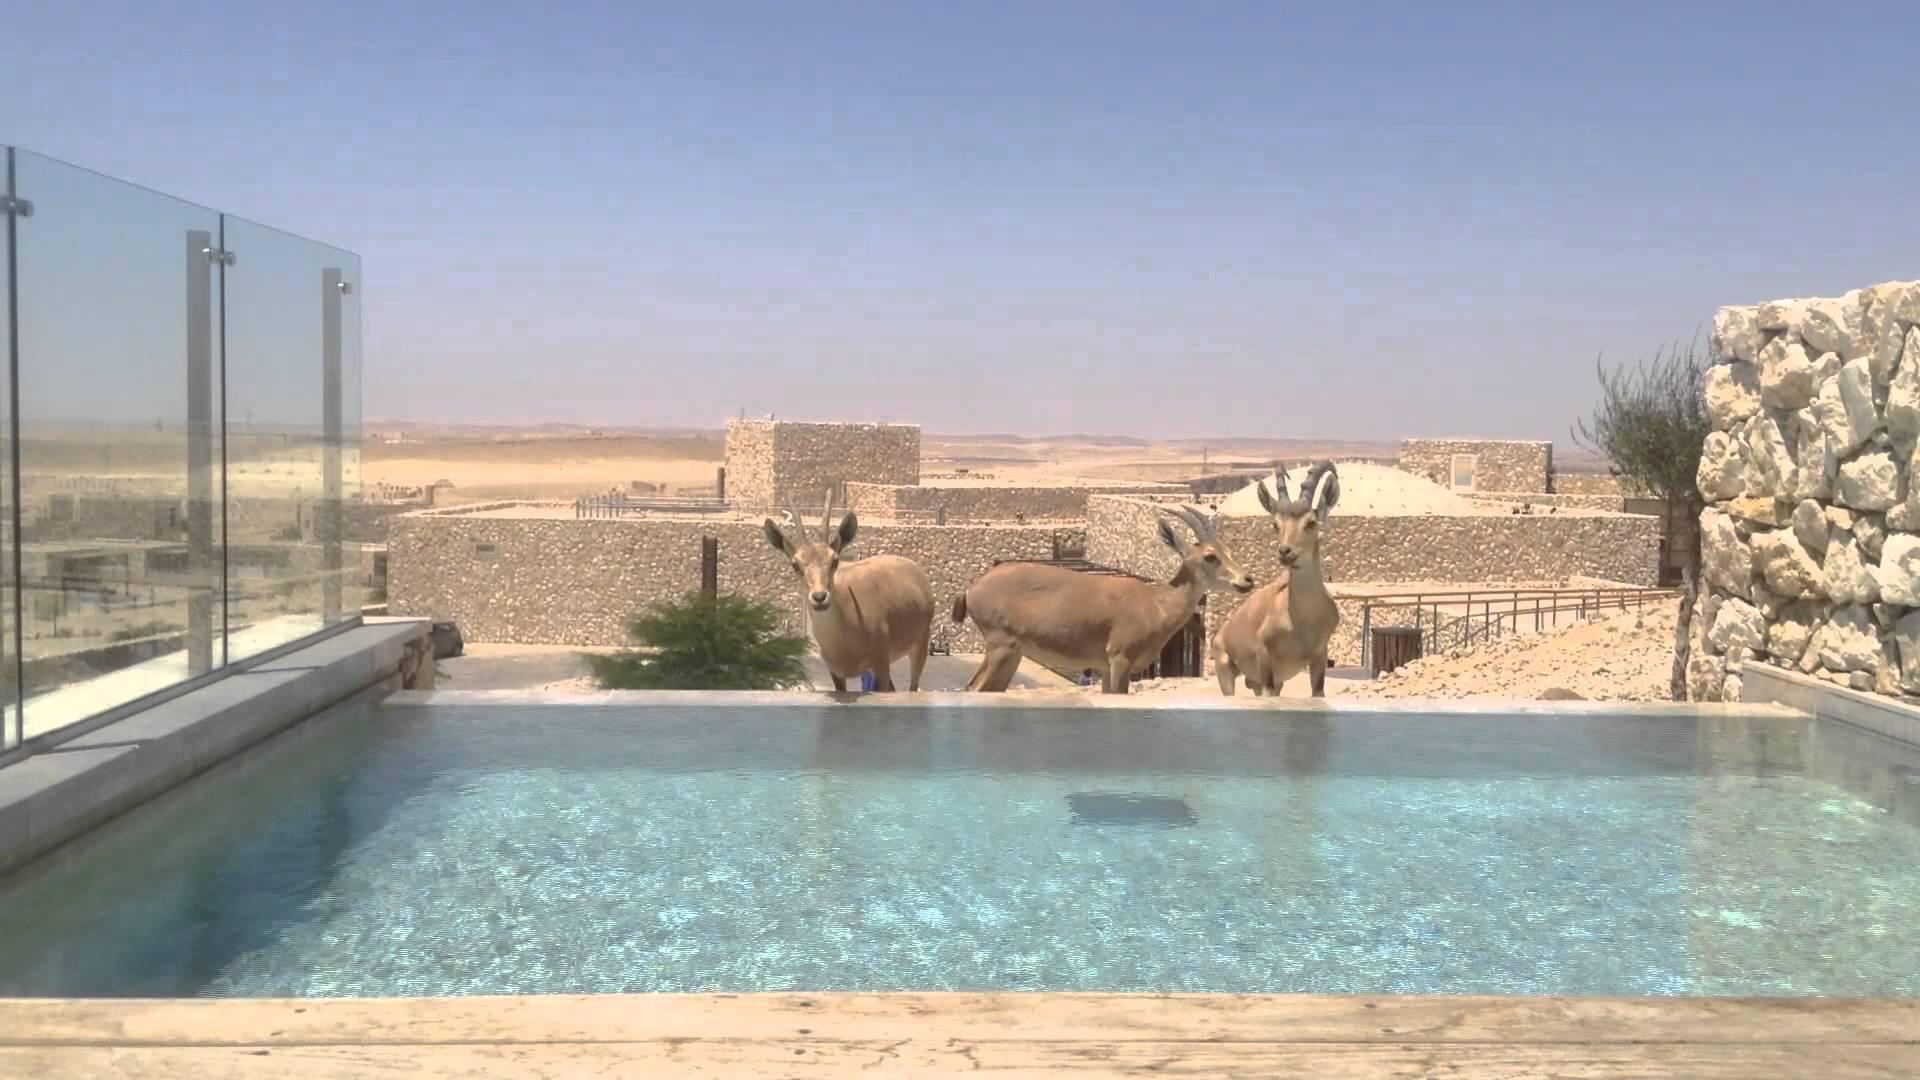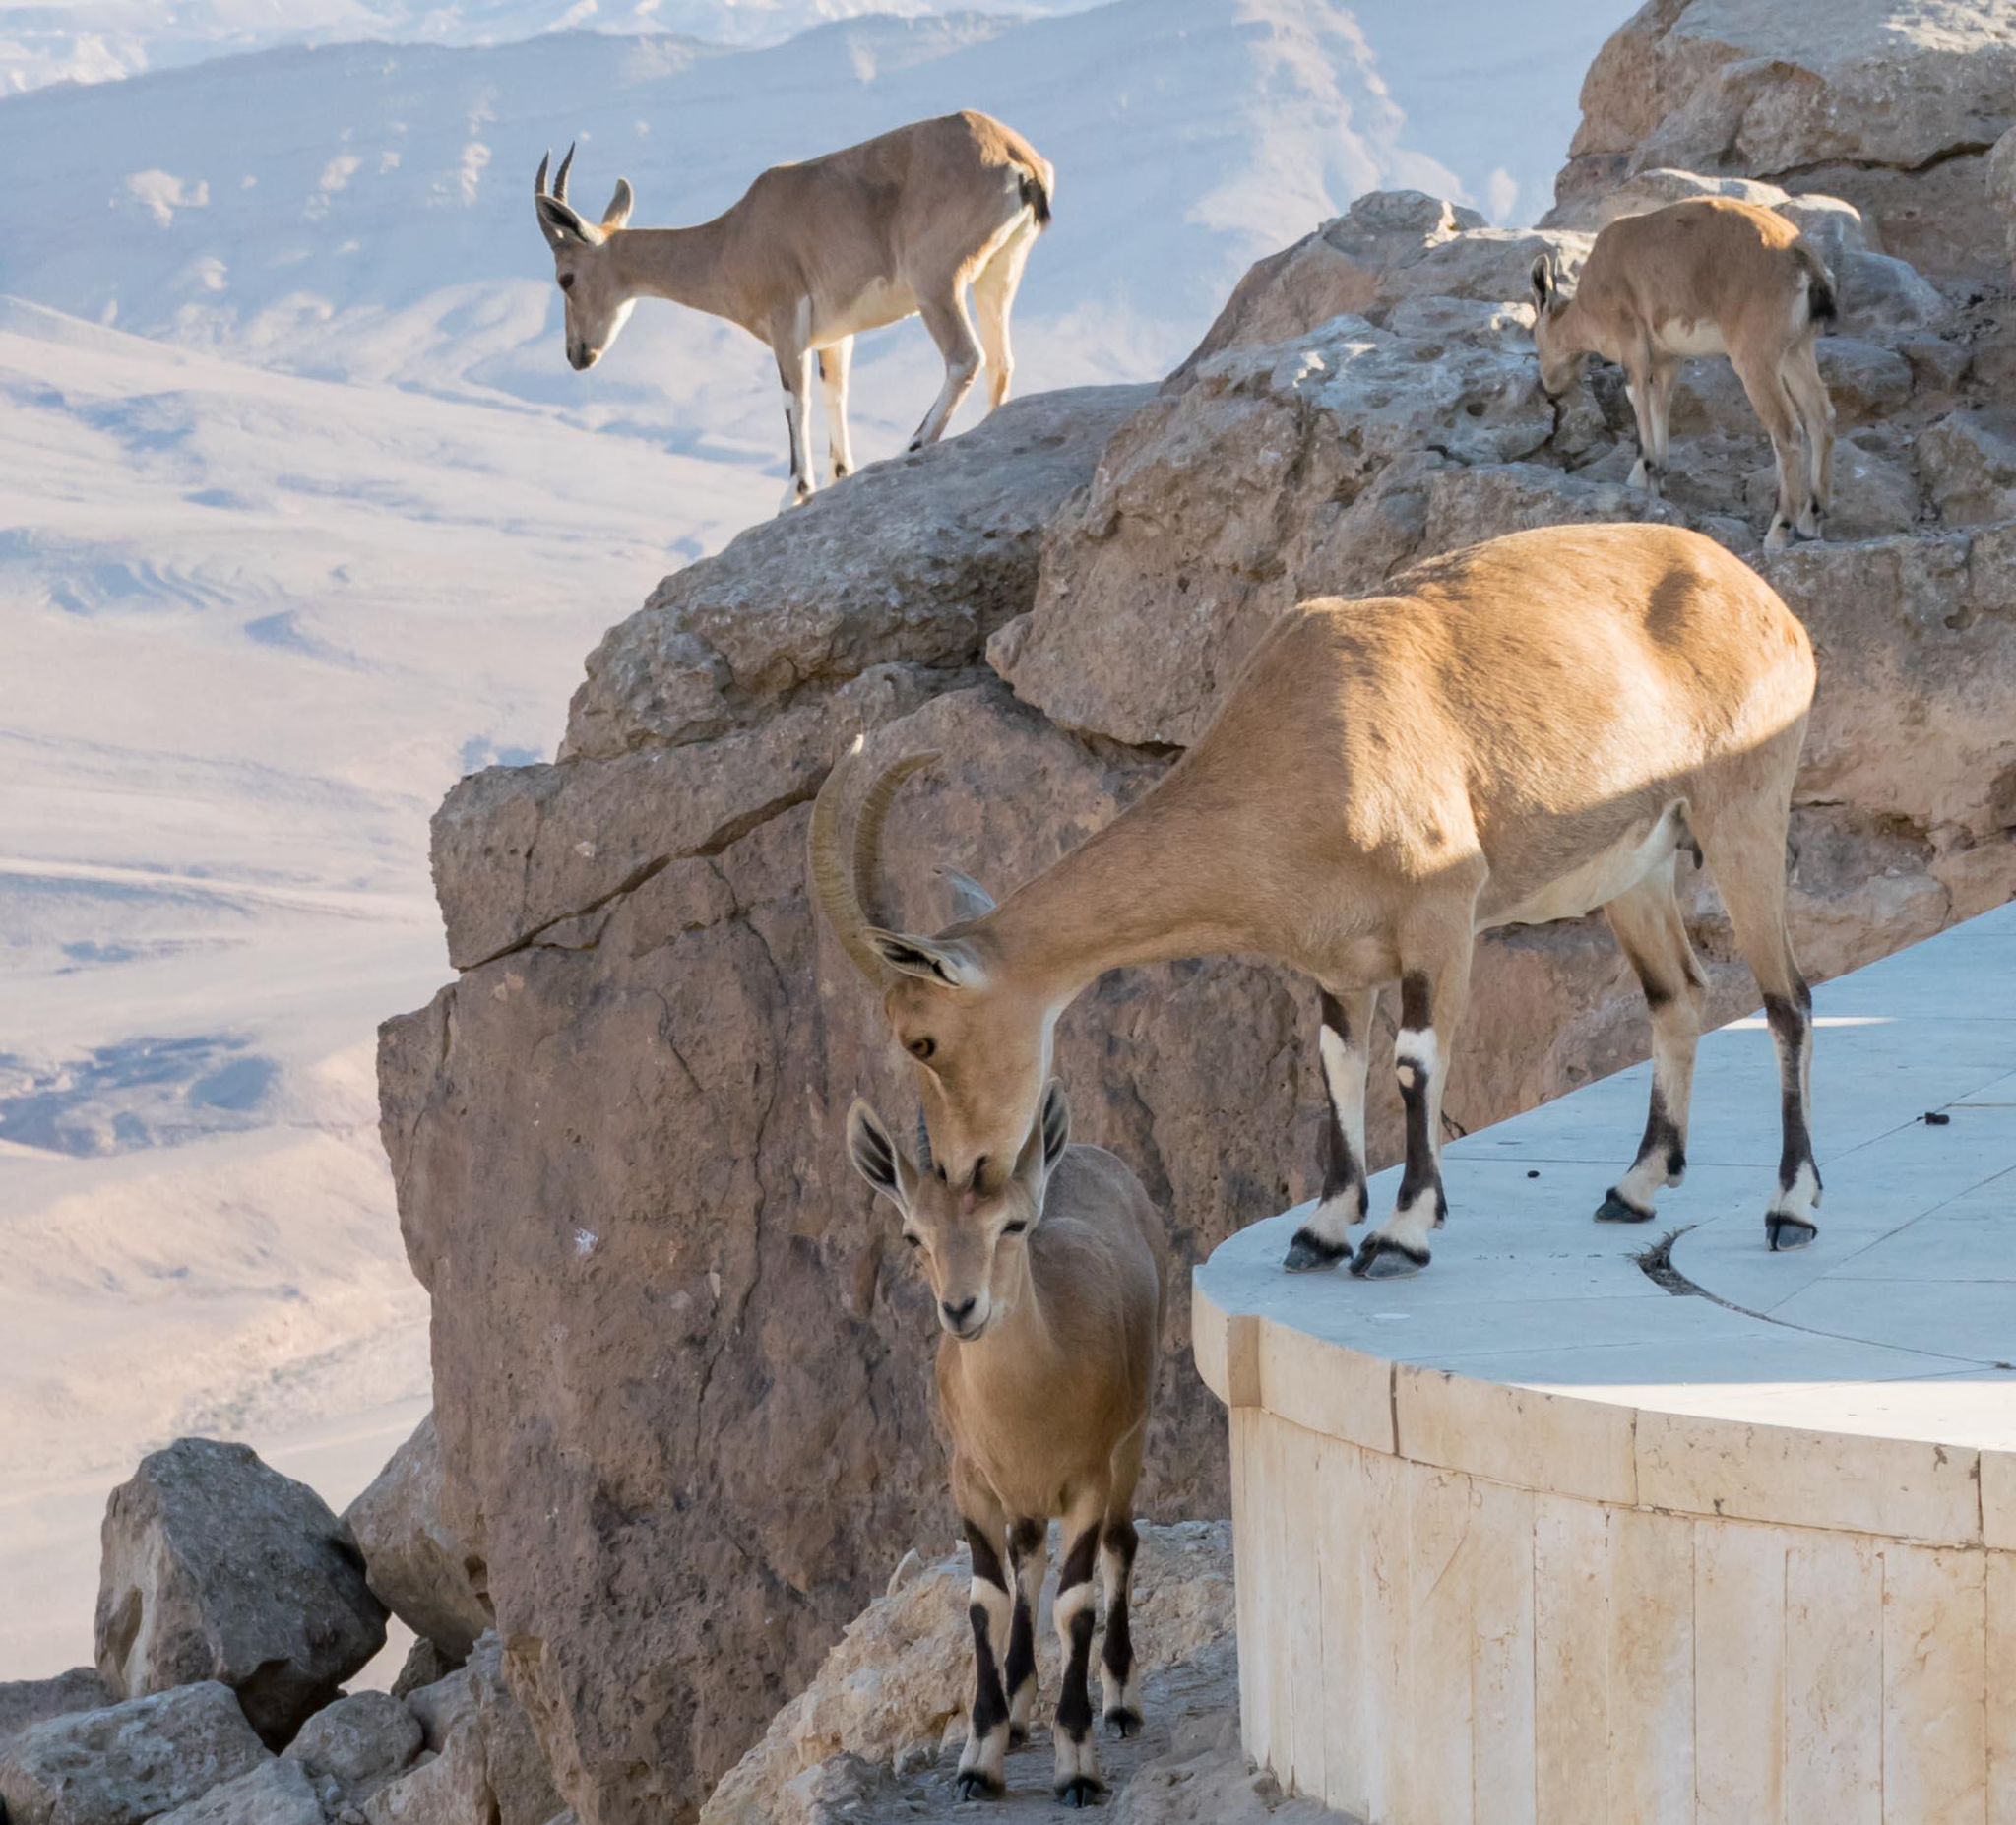The first image is the image on the left, the second image is the image on the right. For the images shown, is this caption "A single animal is standing on a rocky area in the image on the left." true? Answer yes or no. No. The first image is the image on the left, the second image is the image on the right. Assess this claim about the two images: "An image includes a hooved animal standing on the edge of a low man-made wall.". Correct or not? Answer yes or no. Yes. 